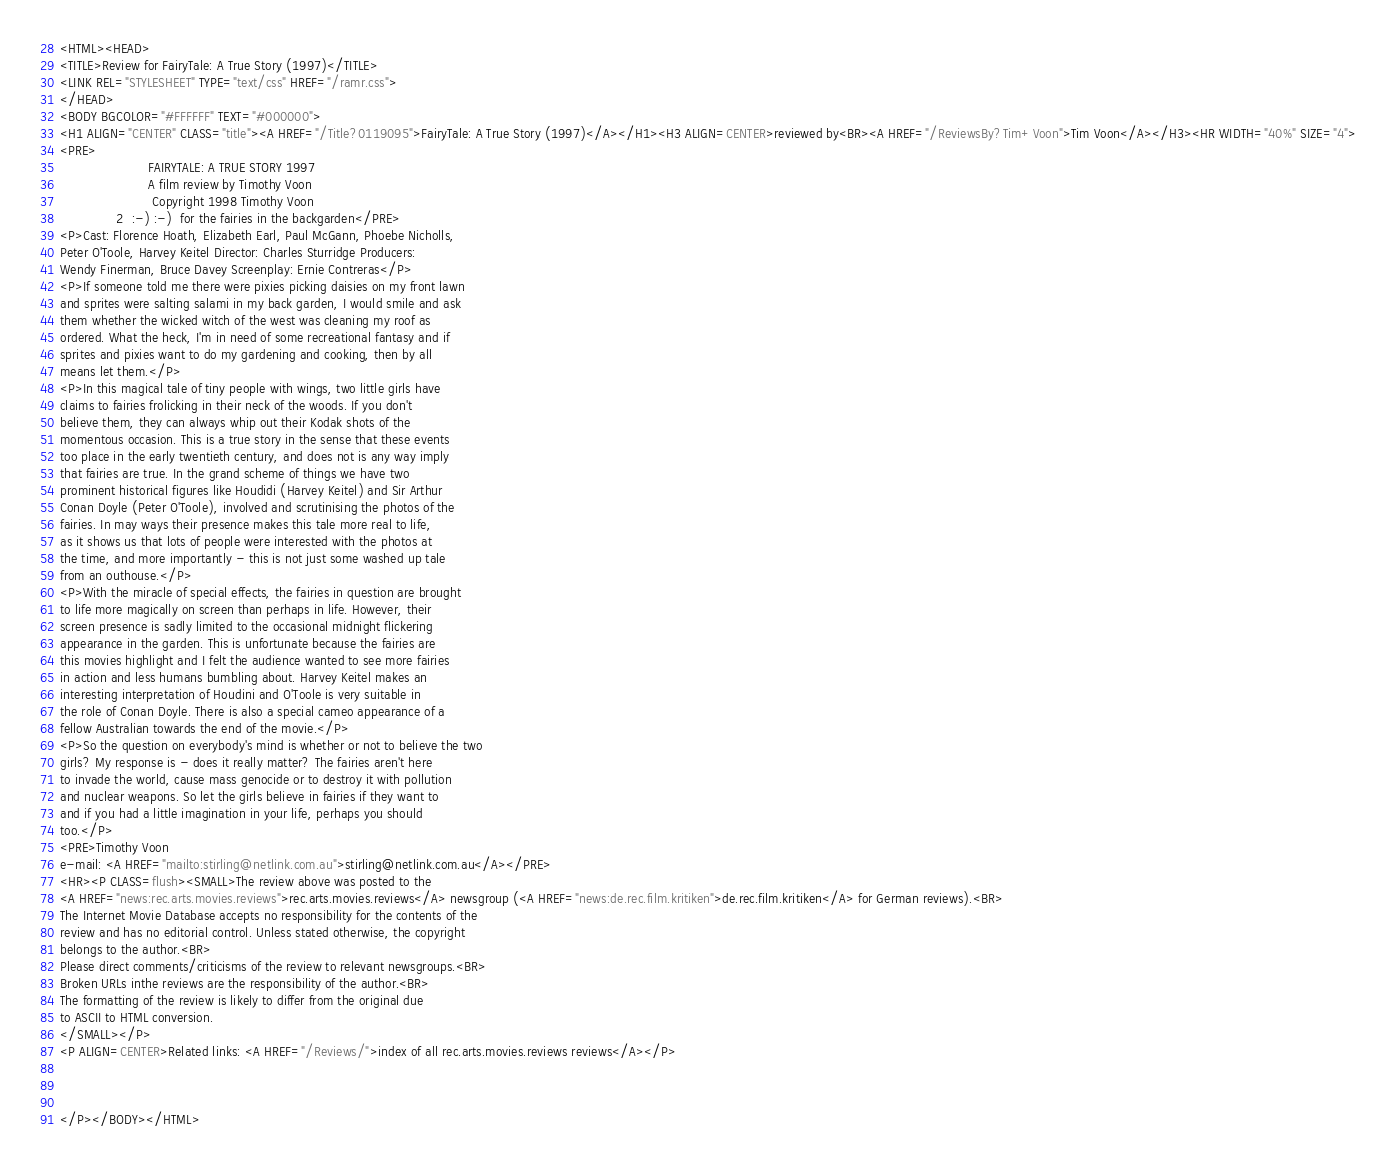Convert code to text. <code><loc_0><loc_0><loc_500><loc_500><_HTML_><HTML><HEAD>
<TITLE>Review for FairyTale: A True Story (1997)</TITLE>
<LINK REL="STYLESHEET" TYPE="text/css" HREF="/ramr.css">
</HEAD>
<BODY BGCOLOR="#FFFFFF" TEXT="#000000">
<H1 ALIGN="CENTER" CLASS="title"><A HREF="/Title?0119095">FairyTale: A True Story (1997)</A></H1><H3 ALIGN=CENTER>reviewed by<BR><A HREF="/ReviewsBy?Tim+Voon">Tim Voon</A></H3><HR WIDTH="40%" SIZE="4">
<PRE>
                      FAIRYTALE: A TRUE STORY 1997
                      A film review by Timothy Voon
                       Copyright 1998 Timothy Voon
              2  :-) :-)  for the fairies in the backgarden</PRE>
<P>Cast: Florence Hoath, Elizabeth Earl, Paul McGann, Phoebe Nicholls,
Peter O'Toole, Harvey Keitel Director: Charles Sturridge Producers:
Wendy Finerman, Bruce Davey Screenplay: Ernie Contreras</P>
<P>If someone told me there were pixies picking daisies on my front lawn
and sprites were salting salami in my back garden, I would smile and ask
them whether the wicked witch of the west was cleaning my roof as
ordered. What the heck, I'm in need of some recreational fantasy and if
sprites and pixies want to do my gardening and cooking, then by all
means let them.</P>
<P>In this magical tale of tiny people with wings, two little girls have
claims to fairies frolicking in their neck of the woods. If you don't
believe them, they can always whip out their Kodak shots of the
momentous occasion. This is a true story in the sense that these events
too place in the early twentieth century, and does not is any way imply
that fairies are true. In the grand scheme of things we have two
prominent historical figures like Houdidi (Harvey Keitel) and Sir Arthur
Conan Doyle (Peter O'Toole), involved and scrutinising the photos of the
fairies. In may ways their presence makes this tale more real to life,
as it shows us that lots of people were interested with the photos at
the time, and more importantly - this is not just some washed up tale
from an outhouse.</P>
<P>With the miracle of special effects, the fairies in question are brought
to life more magically on screen than perhaps in life. However, their
screen presence is sadly limited to the occasional midnight flickering
appearance in the garden. This is unfortunate because the fairies are
this movies highlight and I felt the audience wanted to see more fairies
in action and less humans bumbling about. Harvey Keitel makes an
interesting interpretation of Houdini and O'Toole is very suitable in
the role of Conan Doyle. There is also a special cameo appearance of a
fellow Australian towards the end of the movie.</P>
<P>So the question on everybody's mind is whether or not to believe the two
girls? My response is - does it really matter? The fairies aren't here
to invade the world, cause mass genocide or to destroy it with pollution
and nuclear weapons. So let the girls believe in fairies if they want to
and if you had a little imagination in your life, perhaps you should
too.</P>
<PRE>Timothy Voon
e-mail: <A HREF="mailto:stirling@netlink.com.au">stirling@netlink.com.au</A></PRE>
<HR><P CLASS=flush><SMALL>The review above was posted to the
<A HREF="news:rec.arts.movies.reviews">rec.arts.movies.reviews</A> newsgroup (<A HREF="news:de.rec.film.kritiken">de.rec.film.kritiken</A> for German reviews).<BR>
The Internet Movie Database accepts no responsibility for the contents of the
review and has no editorial control. Unless stated otherwise, the copyright
belongs to the author.<BR>
Please direct comments/criticisms of the review to relevant newsgroups.<BR>
Broken URLs inthe reviews are the responsibility of the author.<BR>
The formatting of the review is likely to differ from the original due
to ASCII to HTML conversion.
</SMALL></P>
<P ALIGN=CENTER>Related links: <A HREF="/Reviews/">index of all rec.arts.movies.reviews reviews</A></P>



</P></BODY></HTML>
</code> 